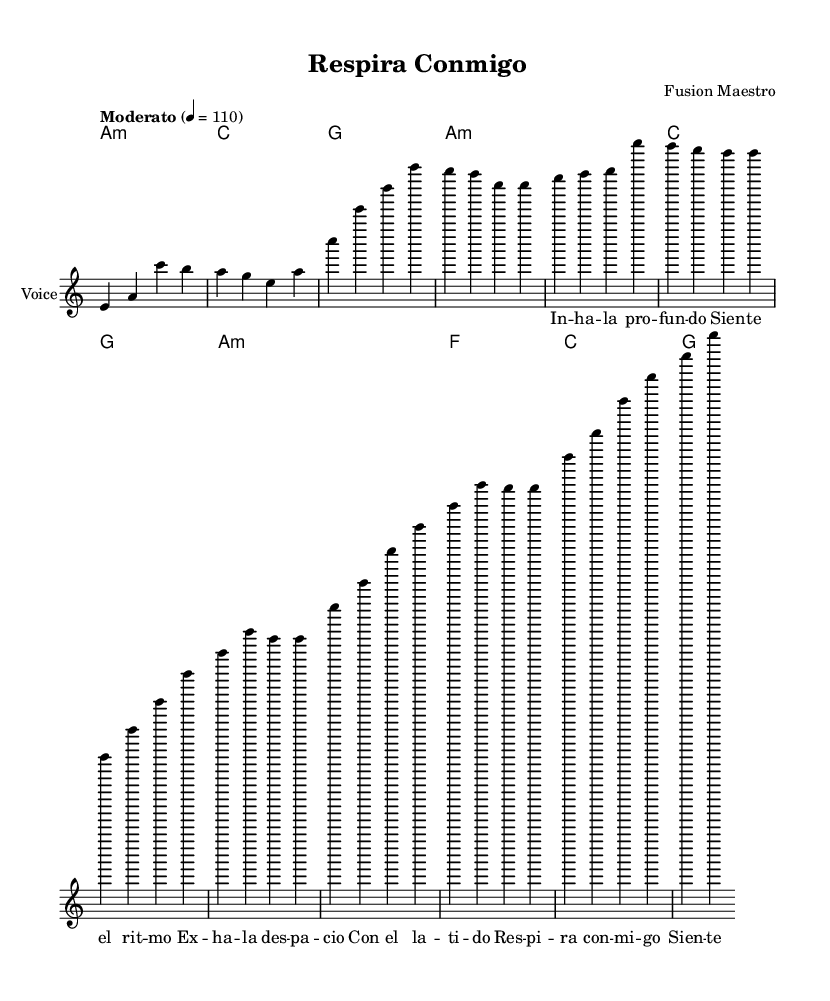What is the key signature of this music? The key signature is A minor, which has no sharps or flats.
Answer: A minor What is the time signature of this piece? The time signature is 4/4, indicating four beats per measure.
Answer: 4/4 What is the tempo marking indicated in the score? The tempo marking is "Moderato" with a pace of 110 beats per minute.
Answer: Moderato 4 = 110 How many measures are in the verse section? The verse section consists of two measures in the score indicated for the verse after the intro.
Answer: 8 measures What lyrical theme does the chorus emphasize? The chorus emphasizes the importance of breathing in rhythm with the music, as suggested by the lyrics "Respira conmigo."
Answer: Breathing What harmony chord follows the chorus? The chord following the chorus is G major based on the provided chord progression.
Answer: G Which element in the lyrics indicates breath control? The mention of "Respira" directly ties to the concept of breath control.
Answer: Respira 